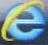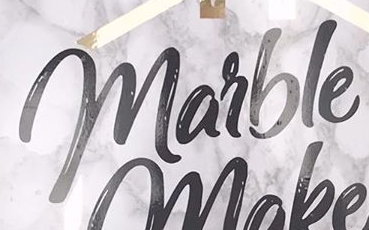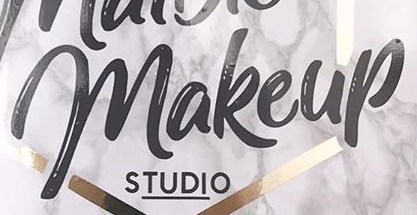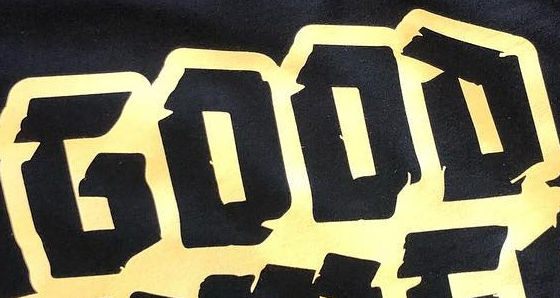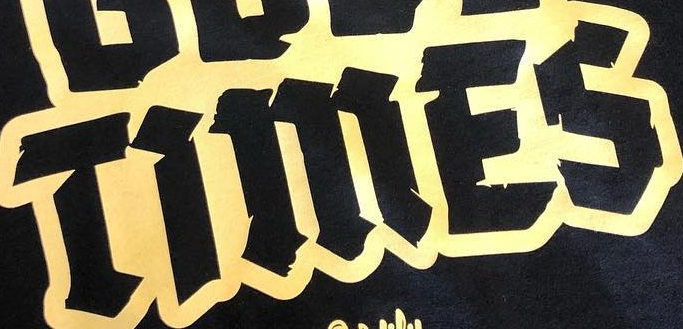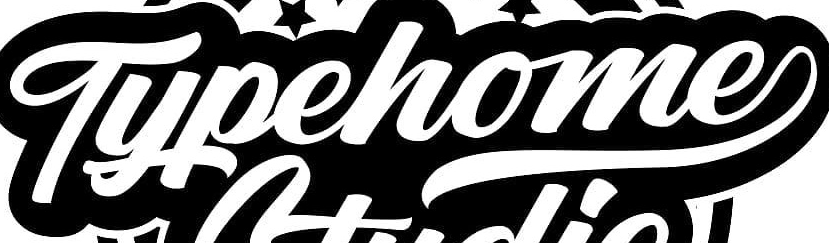What words can you see in these images in sequence, separated by a semicolon? e; marble; makeup; GOOD; TiMES; Typehome 